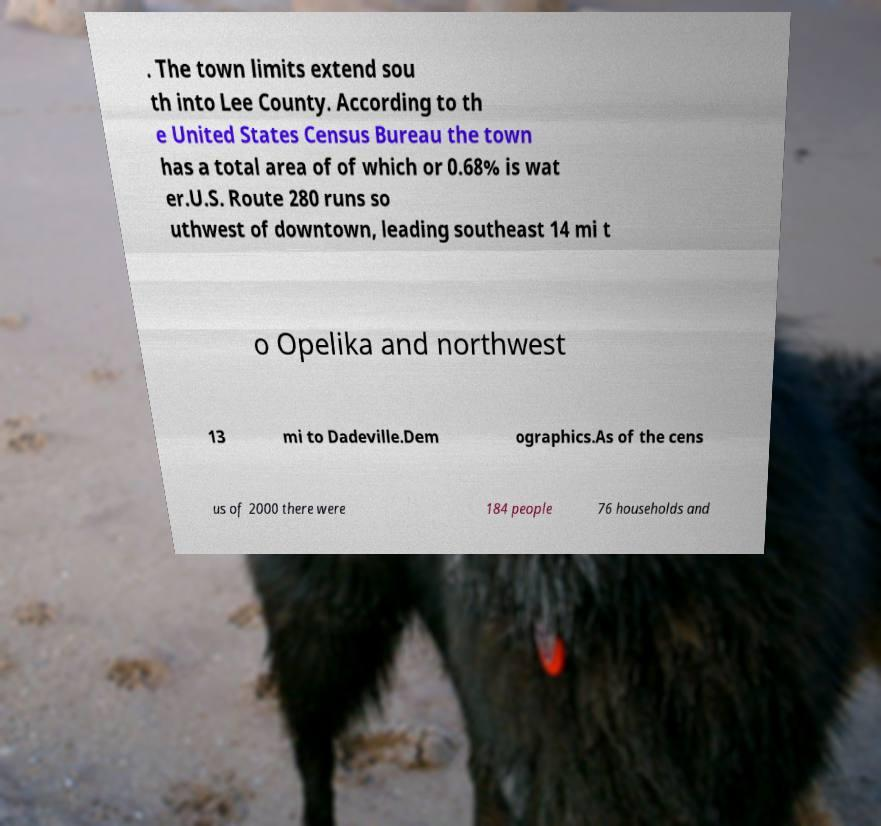Could you assist in decoding the text presented in this image and type it out clearly? . The town limits extend sou th into Lee County. According to th e United States Census Bureau the town has a total area of of which or 0.68% is wat er.U.S. Route 280 runs so uthwest of downtown, leading southeast 14 mi t o Opelika and northwest 13 mi to Dadeville.Dem ographics.As of the cens us of 2000 there were 184 people 76 households and 